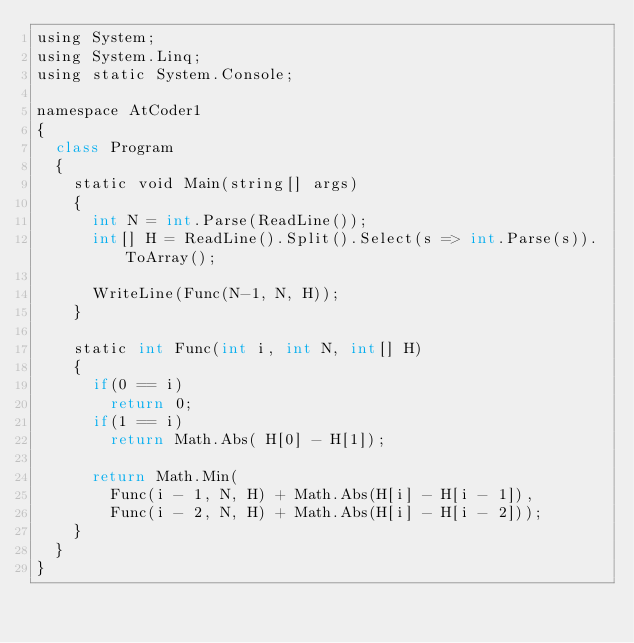<code> <loc_0><loc_0><loc_500><loc_500><_Python_>using System;
using System.Linq;
using static System.Console;

namespace AtCoder1
{
	class Program
	{
		static void Main(string[] args)
		{
			int N = int.Parse(ReadLine());
			int[] H = ReadLine().Split().Select(s => int.Parse(s)).ToArray();

			WriteLine(Func(N-1, N, H));
		}

		static int Func(int i, int N, int[] H)
		{
			if(0 == i)
				return 0;
			if(1 == i)
				return Math.Abs( H[0] - H[1]);

			return Math.Min(
				Func(i - 1, N, H) + Math.Abs(H[i] - H[i - 1]),
				Func(i - 2, N, H) + Math.Abs(H[i] - H[i - 2]));
		}
	}
}
</code> 